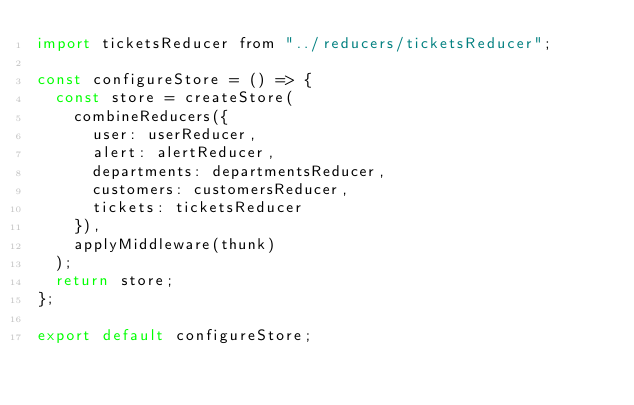Convert code to text. <code><loc_0><loc_0><loc_500><loc_500><_JavaScript_>import ticketsReducer from "../reducers/ticketsReducer";

const configureStore = () => {
  const store = createStore(
    combineReducers({
      user: userReducer,
      alert: alertReducer,
      departments: departmentsReducer,
      customers: customersReducer,
      tickets: ticketsReducer
    }),
    applyMiddleware(thunk)
  );
  return store;
};

export default configureStore;
</code> 